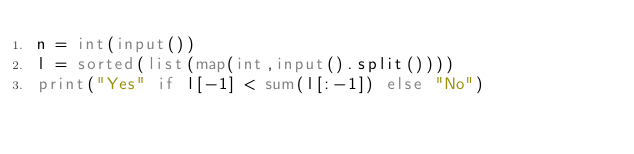<code> <loc_0><loc_0><loc_500><loc_500><_Python_>n = int(input())
l = sorted(list(map(int,input().split())))
print("Yes" if l[-1] < sum(l[:-1]) else "No")</code> 